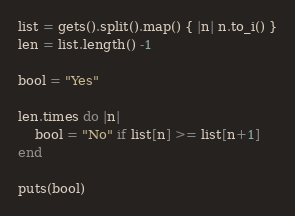<code> <loc_0><loc_0><loc_500><loc_500><_Ruby_>list = gets().split().map() { |n| n.to_i() }
len = list.length() -1 

bool = "Yes"

len.times do |n|
    bool = "No" if list[n] >= list[n+1]
end

puts(bool)


</code> 